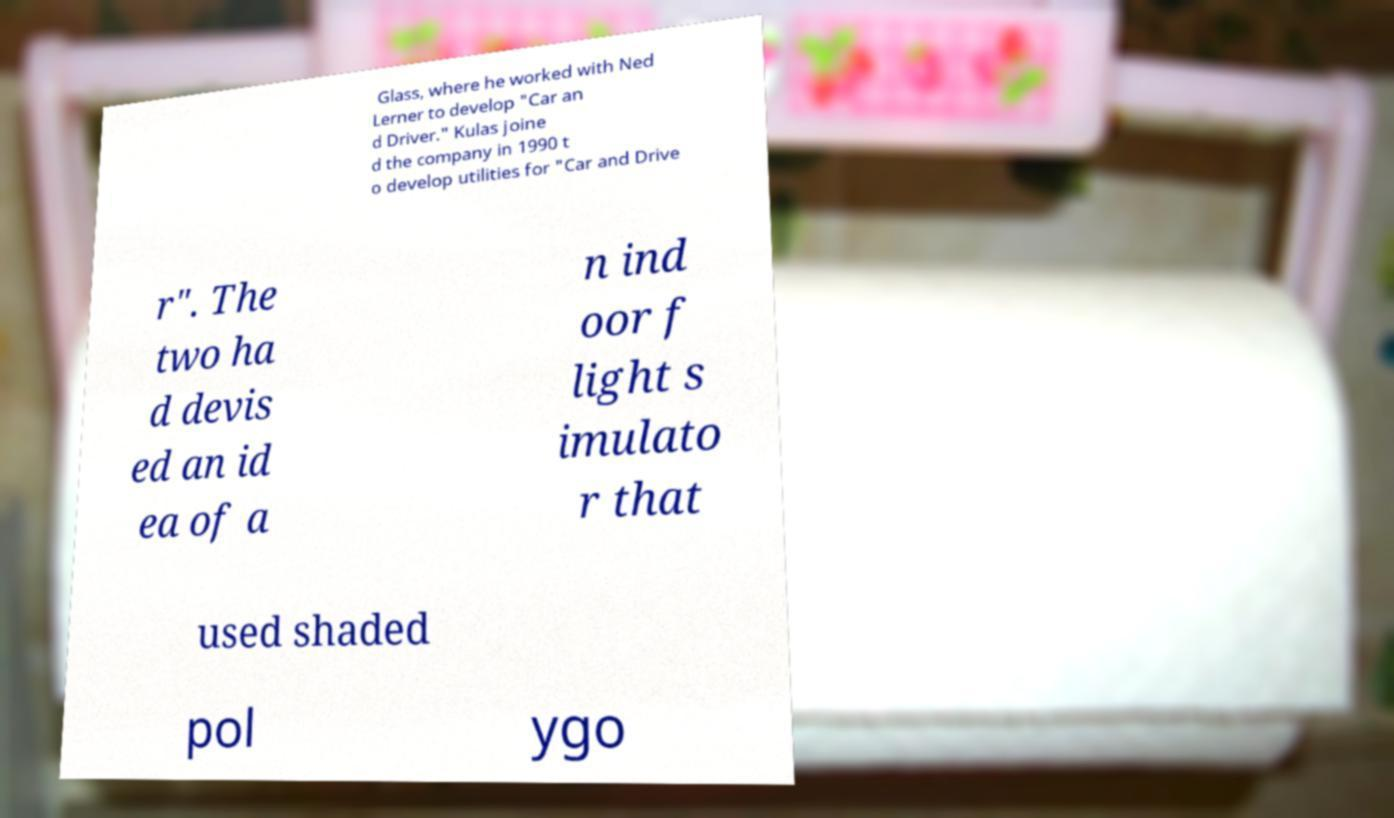Could you extract and type out the text from this image? Glass, where he worked with Ned Lerner to develop "Car an d Driver." Kulas joine d the company in 1990 t o develop utilities for "Car and Drive r". The two ha d devis ed an id ea of a n ind oor f light s imulato r that used shaded pol ygo 